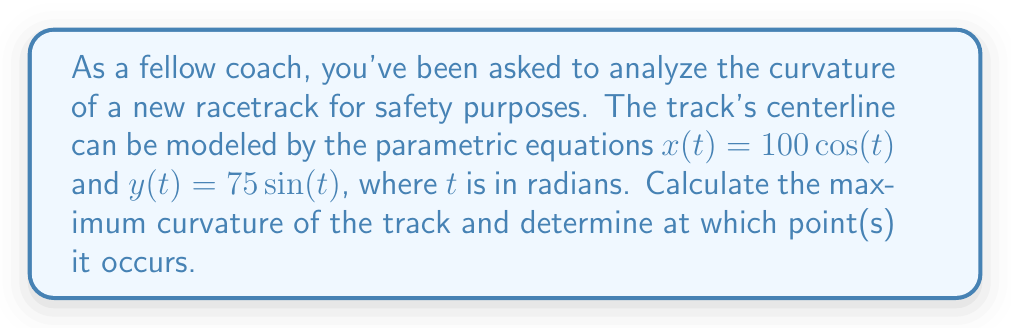Teach me how to tackle this problem. Let's approach this step-by-step using differential geometry:

1) The curvature $\kappa$ of a parametric curve is given by:

   $$\kappa = \frac{|\dot{x}\ddot{y} - \dot{y}\ddot{x}|}{(\dot{x}^2 + \dot{y}^2)^{3/2}}$$

2) First, let's calculate the first and second derivatives:
   
   $\dot{x} = -100\sin(t)$, $\ddot{x} = -100\cos(t)$
   $\dot{y} = 75\cos(t)$, $\ddot{y} = -75\sin(t)$

3) Now, let's substitute these into the curvature formula:

   $$\kappa = \frac{|(-100\sin(t))(-75\sin(t)) - (75\cos(t))(-100\cos(t))|}{((100\sin(t))^2 + (75\cos(t))^2)^{3/2}}$$

4) Simplify the numerator:

   $$\kappa = \frac{|7500\sin^2(t) + 7500\cos^2(t)|}{(10000\sin^2(t) + 5625\cos^2(t))^{3/2}}$$

5) The numerator simplifies to 7500 (since $\sin^2(t) + \cos^2(t) = 1$):

   $$\kappa = \frac{7500}{(10000\sin^2(t) + 5625\cos^2(t))^{3/2}}$$

6) To find the maximum curvature, we need to minimize the denominator. The denominator is minimized when $\sin^2(t)$ is at its minimum (0) and $\cos^2(t)$ is at its maximum (1), or vice versa.

7) The minimum value of the denominator occurs when $\cos^2(t) = 1$ (and $\sin^2(t) = 0$):

   $$\kappa_{max} = \frac{7500}{(5625)^{3/2}} = \frac{1}{75}$$

8) This occurs at $t = 0$, $\pi$, $2\pi$, etc., which correspond to the points $(100, 0)$, $(-100, 0)$, $(100, 0)$, etc. on the track.
Answer: $\frac{1}{75}$ at $(100, 0)$ and $(-100, 0)$ 